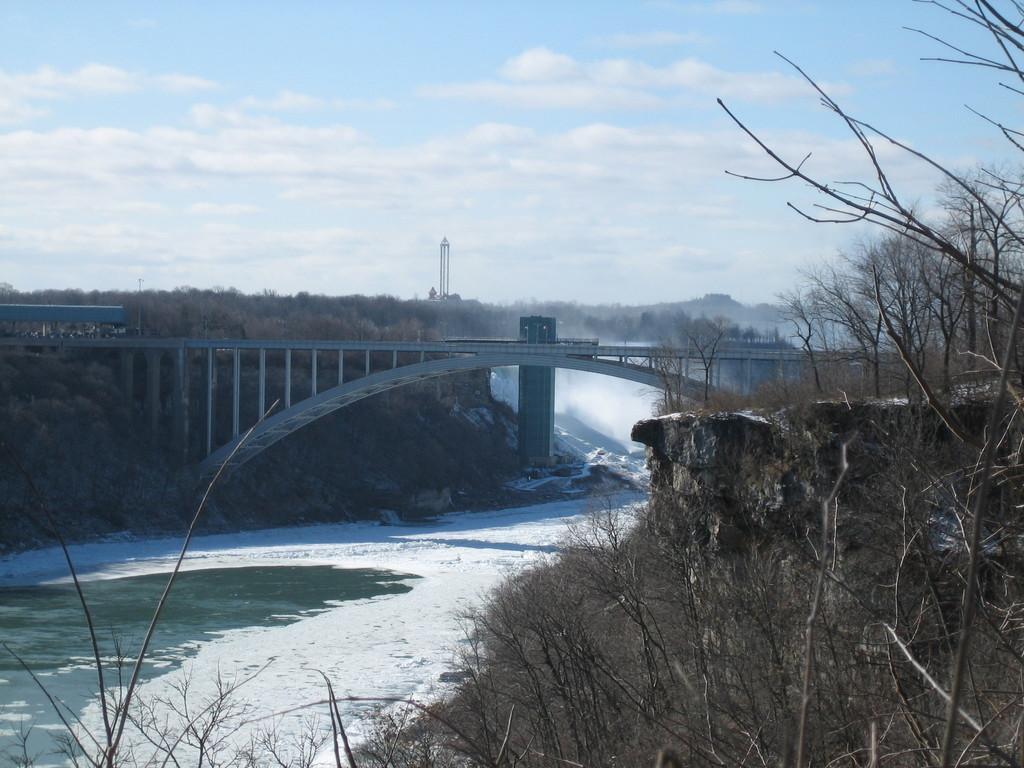How would you summarize this image in a sentence or two? In this picture I can see a bridge and few trees and I can see water and a tower and I can see a blue cloudy sky. 